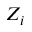<formula> <loc_0><loc_0><loc_500><loc_500>Z _ { i }</formula> 